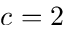Convert formula to latex. <formula><loc_0><loc_0><loc_500><loc_500>c = 2</formula> 